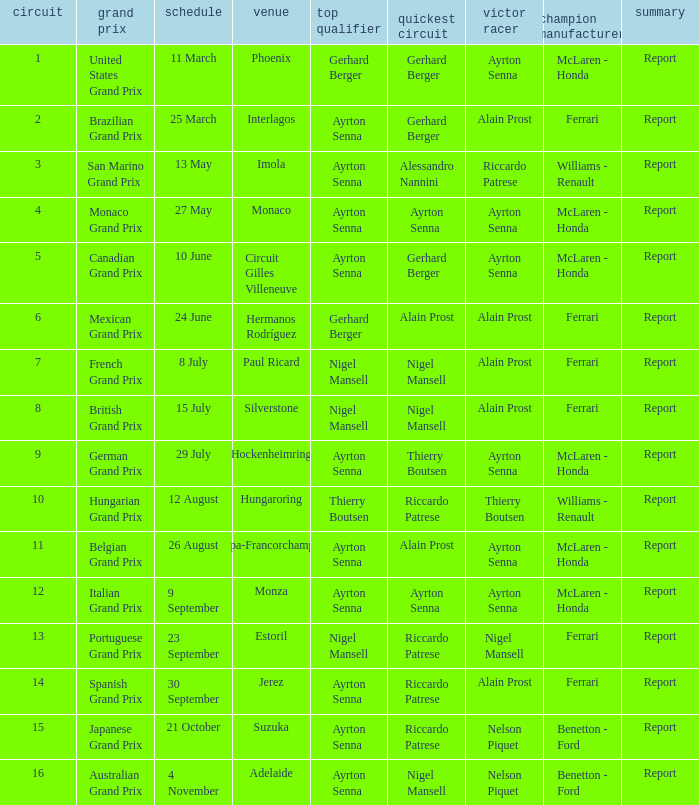What is the Pole Position for the German Grand Prix Ayrton Senna. 